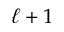<formula> <loc_0><loc_0><loc_500><loc_500>\ell + 1</formula> 